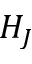<formula> <loc_0><loc_0><loc_500><loc_500>H _ { J }</formula> 